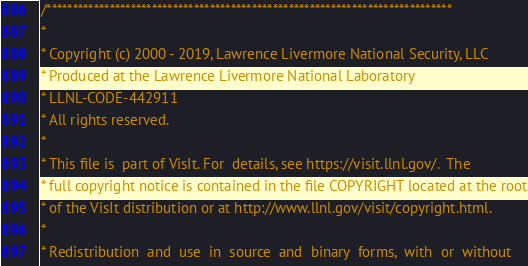<code> <loc_0><loc_0><loc_500><loc_500><_C_>/*****************************************************************************
*
* Copyright (c) 2000 - 2019, Lawrence Livermore National Security, LLC
* Produced at the Lawrence Livermore National Laboratory
* LLNL-CODE-442911
* All rights reserved.
*
* This file is  part of VisIt. For  details, see https://visit.llnl.gov/.  The
* full copyright notice is contained in the file COPYRIGHT located at the root
* of the VisIt distribution or at http://www.llnl.gov/visit/copyright.html.
*
* Redistribution  and  use  in  source  and  binary  forms,  with  or  without</code> 